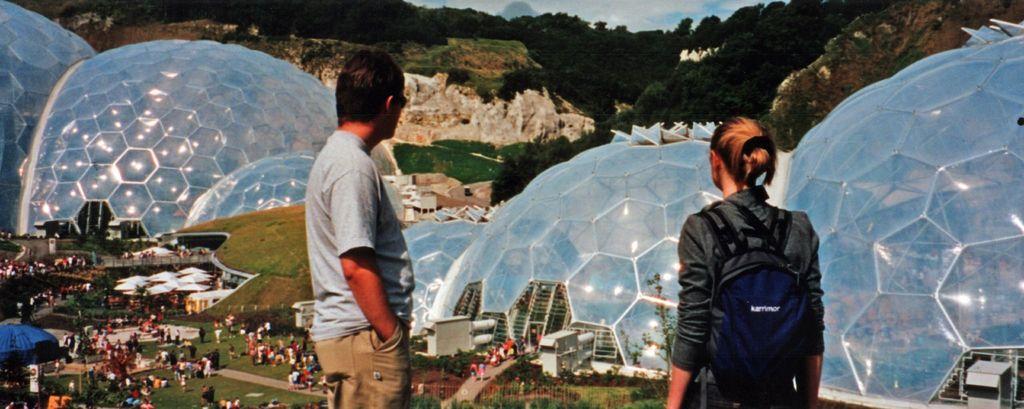Please provide a concise description of this image. In the image we can see there are people standing on the ground and there are lot of people standing on the ground. The ground is covered with grass and there are buildings in the shape of igloo. Behind there are rock hills and there are lot of trees. 